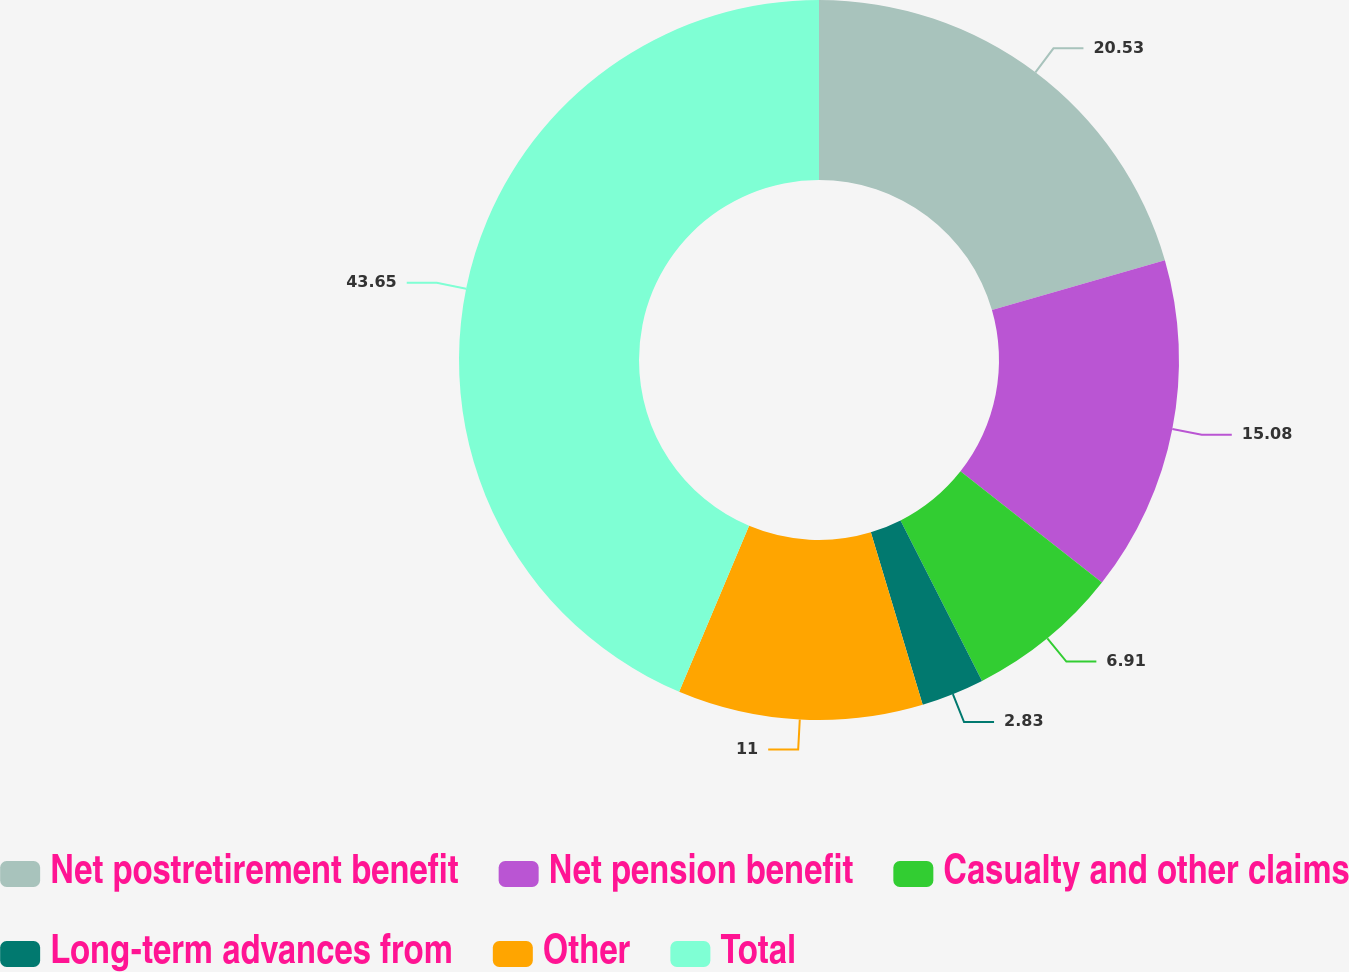Convert chart to OTSL. <chart><loc_0><loc_0><loc_500><loc_500><pie_chart><fcel>Net postretirement benefit<fcel>Net pension benefit<fcel>Casualty and other claims<fcel>Long-term advances from<fcel>Other<fcel>Total<nl><fcel>20.53%<fcel>15.08%<fcel>6.91%<fcel>2.83%<fcel>11.0%<fcel>43.65%<nl></chart> 